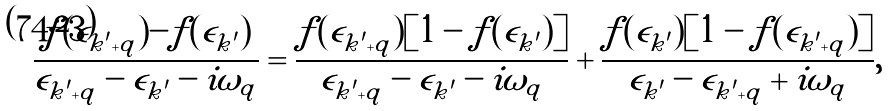<formula> <loc_0><loc_0><loc_500><loc_500>\frac { f ( \epsilon _ { { k } ^ { \prime } + { q } } ) - f ( \epsilon _ { { k } ^ { \prime } } ) } { \epsilon _ { { k } ^ { \prime } + { q } } - \epsilon _ { { k } ^ { \prime } } - i \omega _ { q } } = \frac { f ( \epsilon _ { { k } ^ { \prime } + { q } } ) [ 1 - f ( \epsilon _ { { k } ^ { \prime } } ) ] } { \epsilon _ { { k } ^ { \prime } + { q } } - \epsilon _ { { k } ^ { \prime } } - i \omega _ { q } } + \frac { f ( \epsilon _ { { k } ^ { \prime } } ) [ 1 - f ( \epsilon _ { { k } ^ { \prime } + { q } } ) ] } { \epsilon _ { { k } ^ { \prime } } - \epsilon _ { { k } ^ { \prime } + { q } } + i \omega _ { q } } ,</formula> 